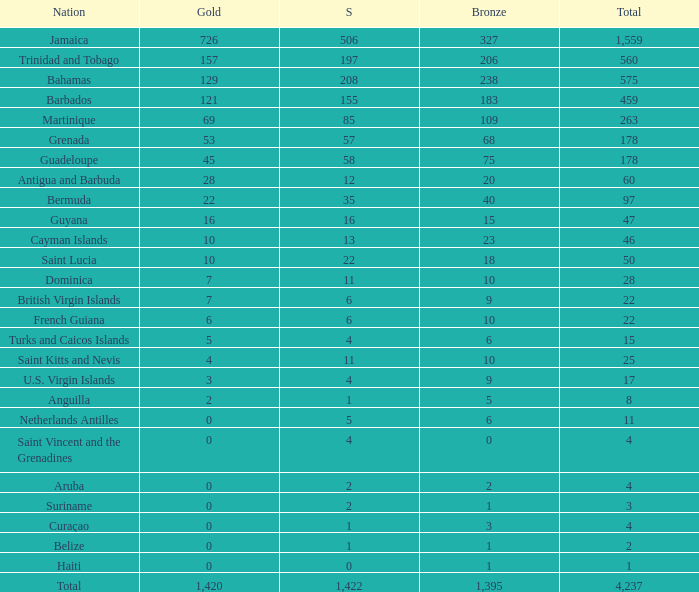What's the sum of Gold with a Bronze that's larger than 15, Silver that's smaller than 197, the Nation of Saint Lucia, and has a Total that is larger than 50? None. 